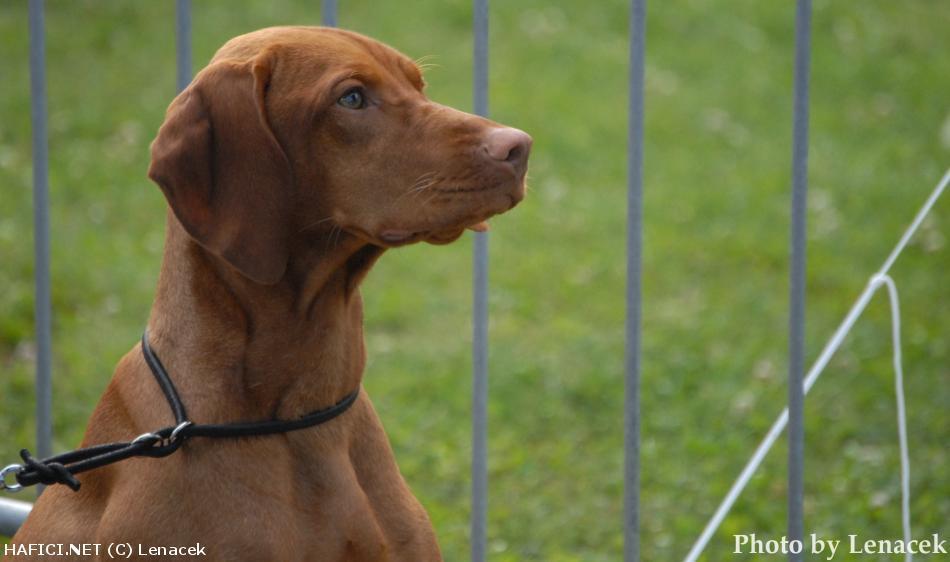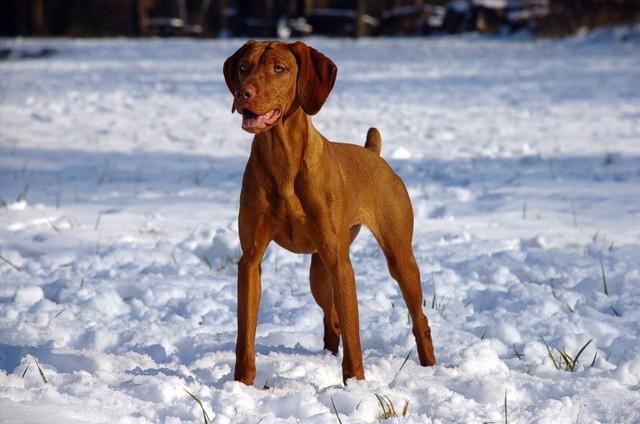The first image is the image on the left, the second image is the image on the right. Analyze the images presented: Is the assertion "One of the images shows a brown dog with one of its front legs raised and the other image shows a brown dog standing in grass." valid? Answer yes or no. No. The first image is the image on the left, the second image is the image on the right. Assess this claim about the two images: "One dog has it's front leg up and bent in a pose.". Correct or not? Answer yes or no. No. 